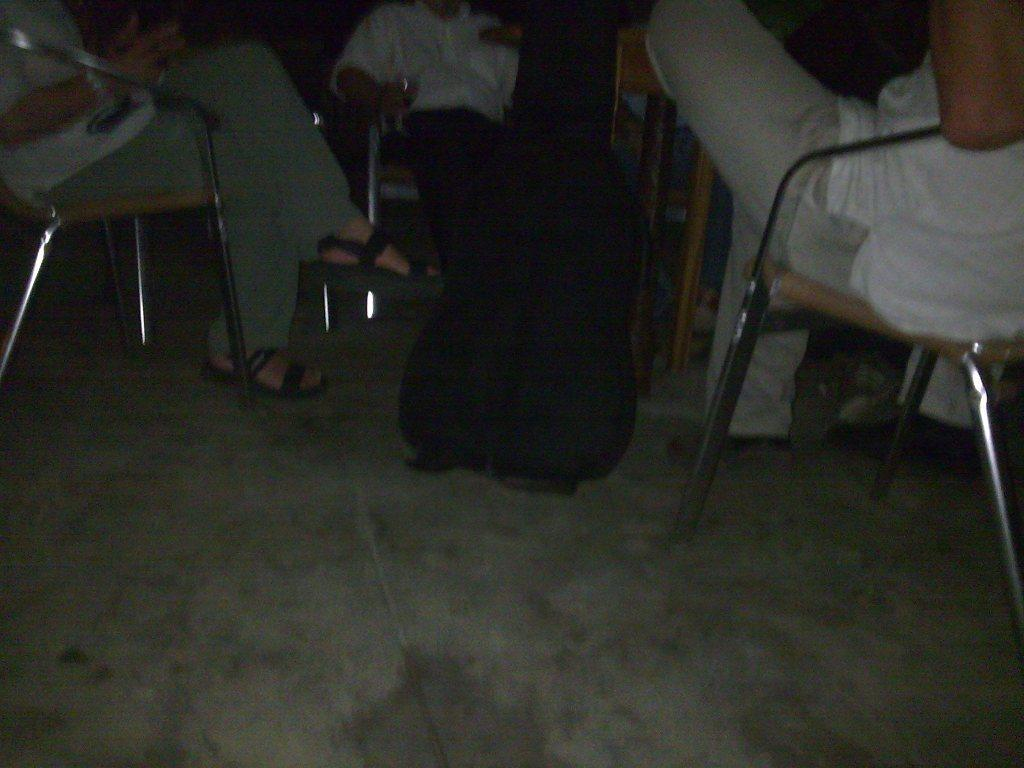How many people are in the image? There are three persons in the image. What are the persons doing in the image? The persons are sitting on chairs. What object can be seen on the floor? There is a bag on the floor. What piece of furniture is present in the image? There is a table in the image. What type of range can be seen in the image? There is no range present in the image. 